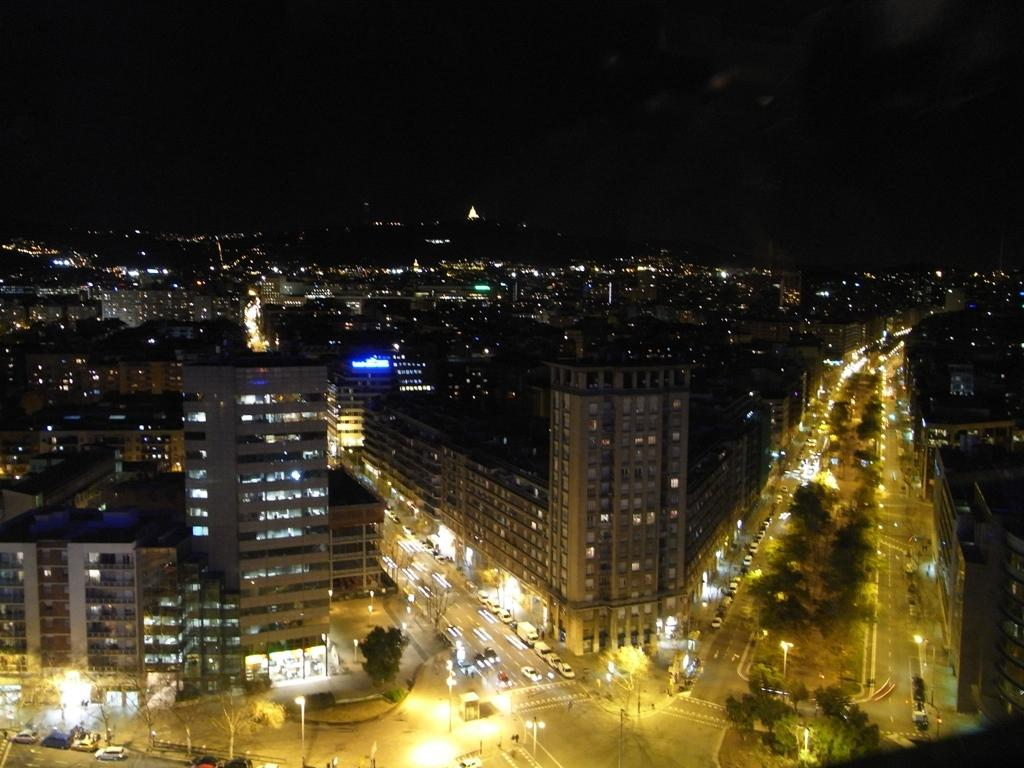What is the time of day depicted in the image? The image is a night view of the city. What structures can be seen in the image? There are buildings in the image. What can be observed illuminating the scene in the image? There are lights visible in the image. What are the poles in the image used for? The poles in the image are likely used for supporting lights or other infrastructure. What type of vegetation is present in the image? There are trees in the image. What type of transportation is visible on the road in the image? There are vehicles on the road in the image. What type of stick can be seen in the image? There is no stick present in the image. What type of lamp is hanging from the trees in the image? There are no lamps hanging from the trees in the image; only lights are visible. 